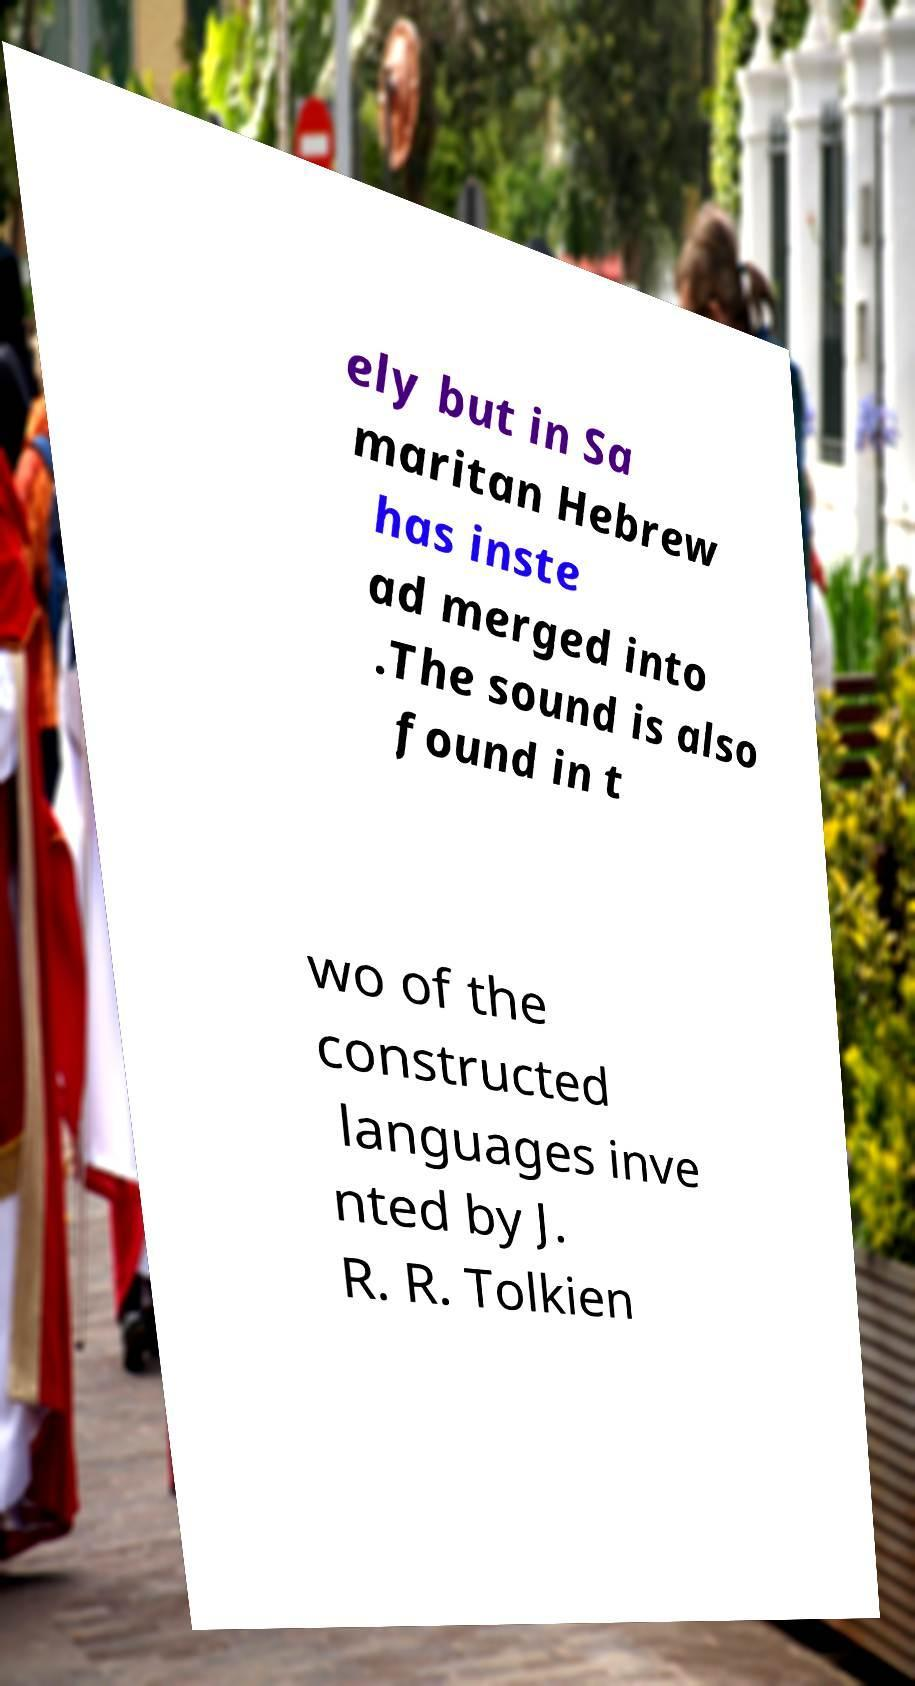Please read and relay the text visible in this image. What does it say? ely but in Sa maritan Hebrew has inste ad merged into .The sound is also found in t wo of the constructed languages inve nted by J. R. R. Tolkien 